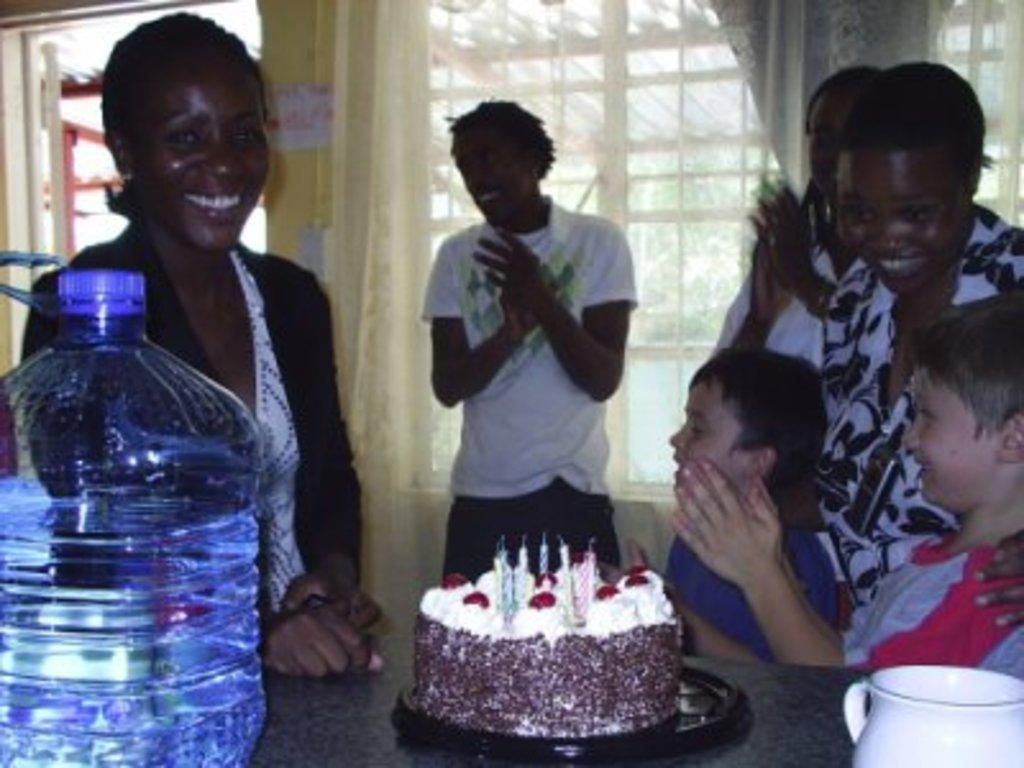Describe this image in one or two sentences. In this image I can see few people were two of them are boys. I can also see a water bottle, cake and a cup. 